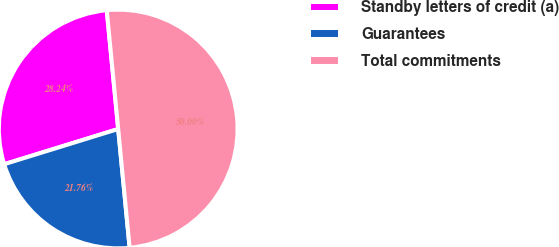Convert chart to OTSL. <chart><loc_0><loc_0><loc_500><loc_500><pie_chart><fcel>Standby letters of credit (a)<fcel>Guarantees<fcel>Total commitments<nl><fcel>28.24%<fcel>21.76%<fcel>50.0%<nl></chart> 